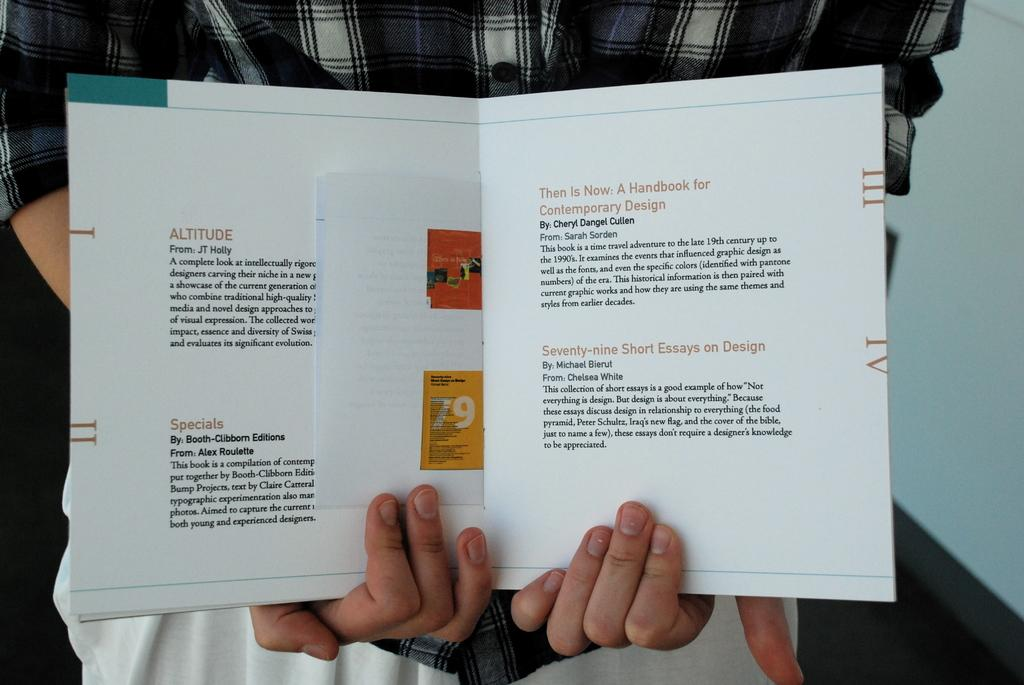<image>
Write a terse but informative summary of the picture. Someone holds open a book that includes short summaries of other books included Altitude, Specials and more. 